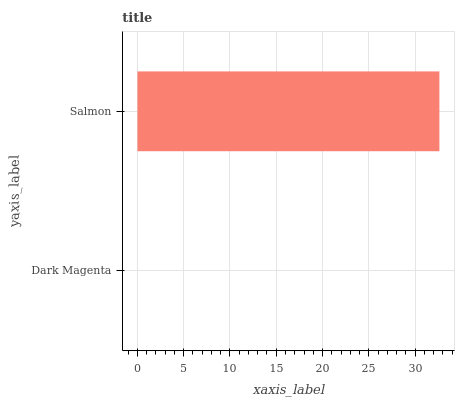Is Dark Magenta the minimum?
Answer yes or no. Yes. Is Salmon the maximum?
Answer yes or no. Yes. Is Salmon the minimum?
Answer yes or no. No. Is Salmon greater than Dark Magenta?
Answer yes or no. Yes. Is Dark Magenta less than Salmon?
Answer yes or no. Yes. Is Dark Magenta greater than Salmon?
Answer yes or no. No. Is Salmon less than Dark Magenta?
Answer yes or no. No. Is Salmon the high median?
Answer yes or no. Yes. Is Dark Magenta the low median?
Answer yes or no. Yes. Is Dark Magenta the high median?
Answer yes or no. No. Is Salmon the low median?
Answer yes or no. No. 